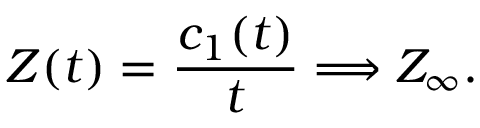<formula> <loc_0><loc_0><loc_500><loc_500>Z ( t ) = \frac { c _ { 1 } ( t ) } { t } \Longrightarrow Z _ { \infty } .</formula> 